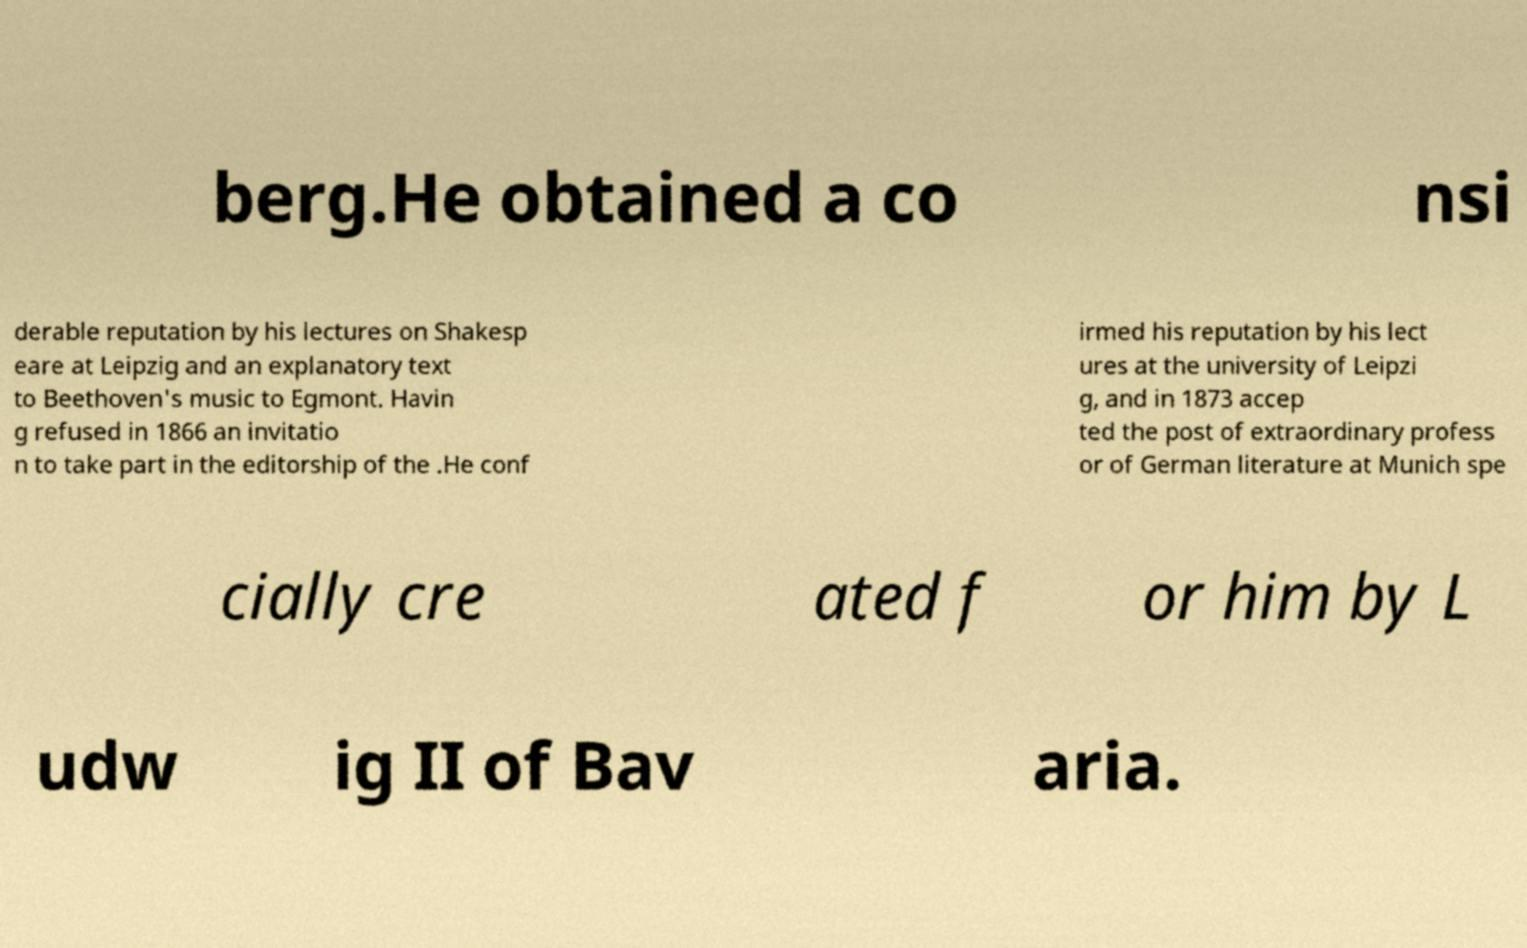I need the written content from this picture converted into text. Can you do that? berg.He obtained a co nsi derable reputation by his lectures on Shakesp eare at Leipzig and an explanatory text to Beethoven's music to Egmont. Havin g refused in 1866 an invitatio n to take part in the editorship of the .He conf irmed his reputation by his lect ures at the university of Leipzi g, and in 1873 accep ted the post of extraordinary profess or of German literature at Munich spe cially cre ated f or him by L udw ig II of Bav aria. 